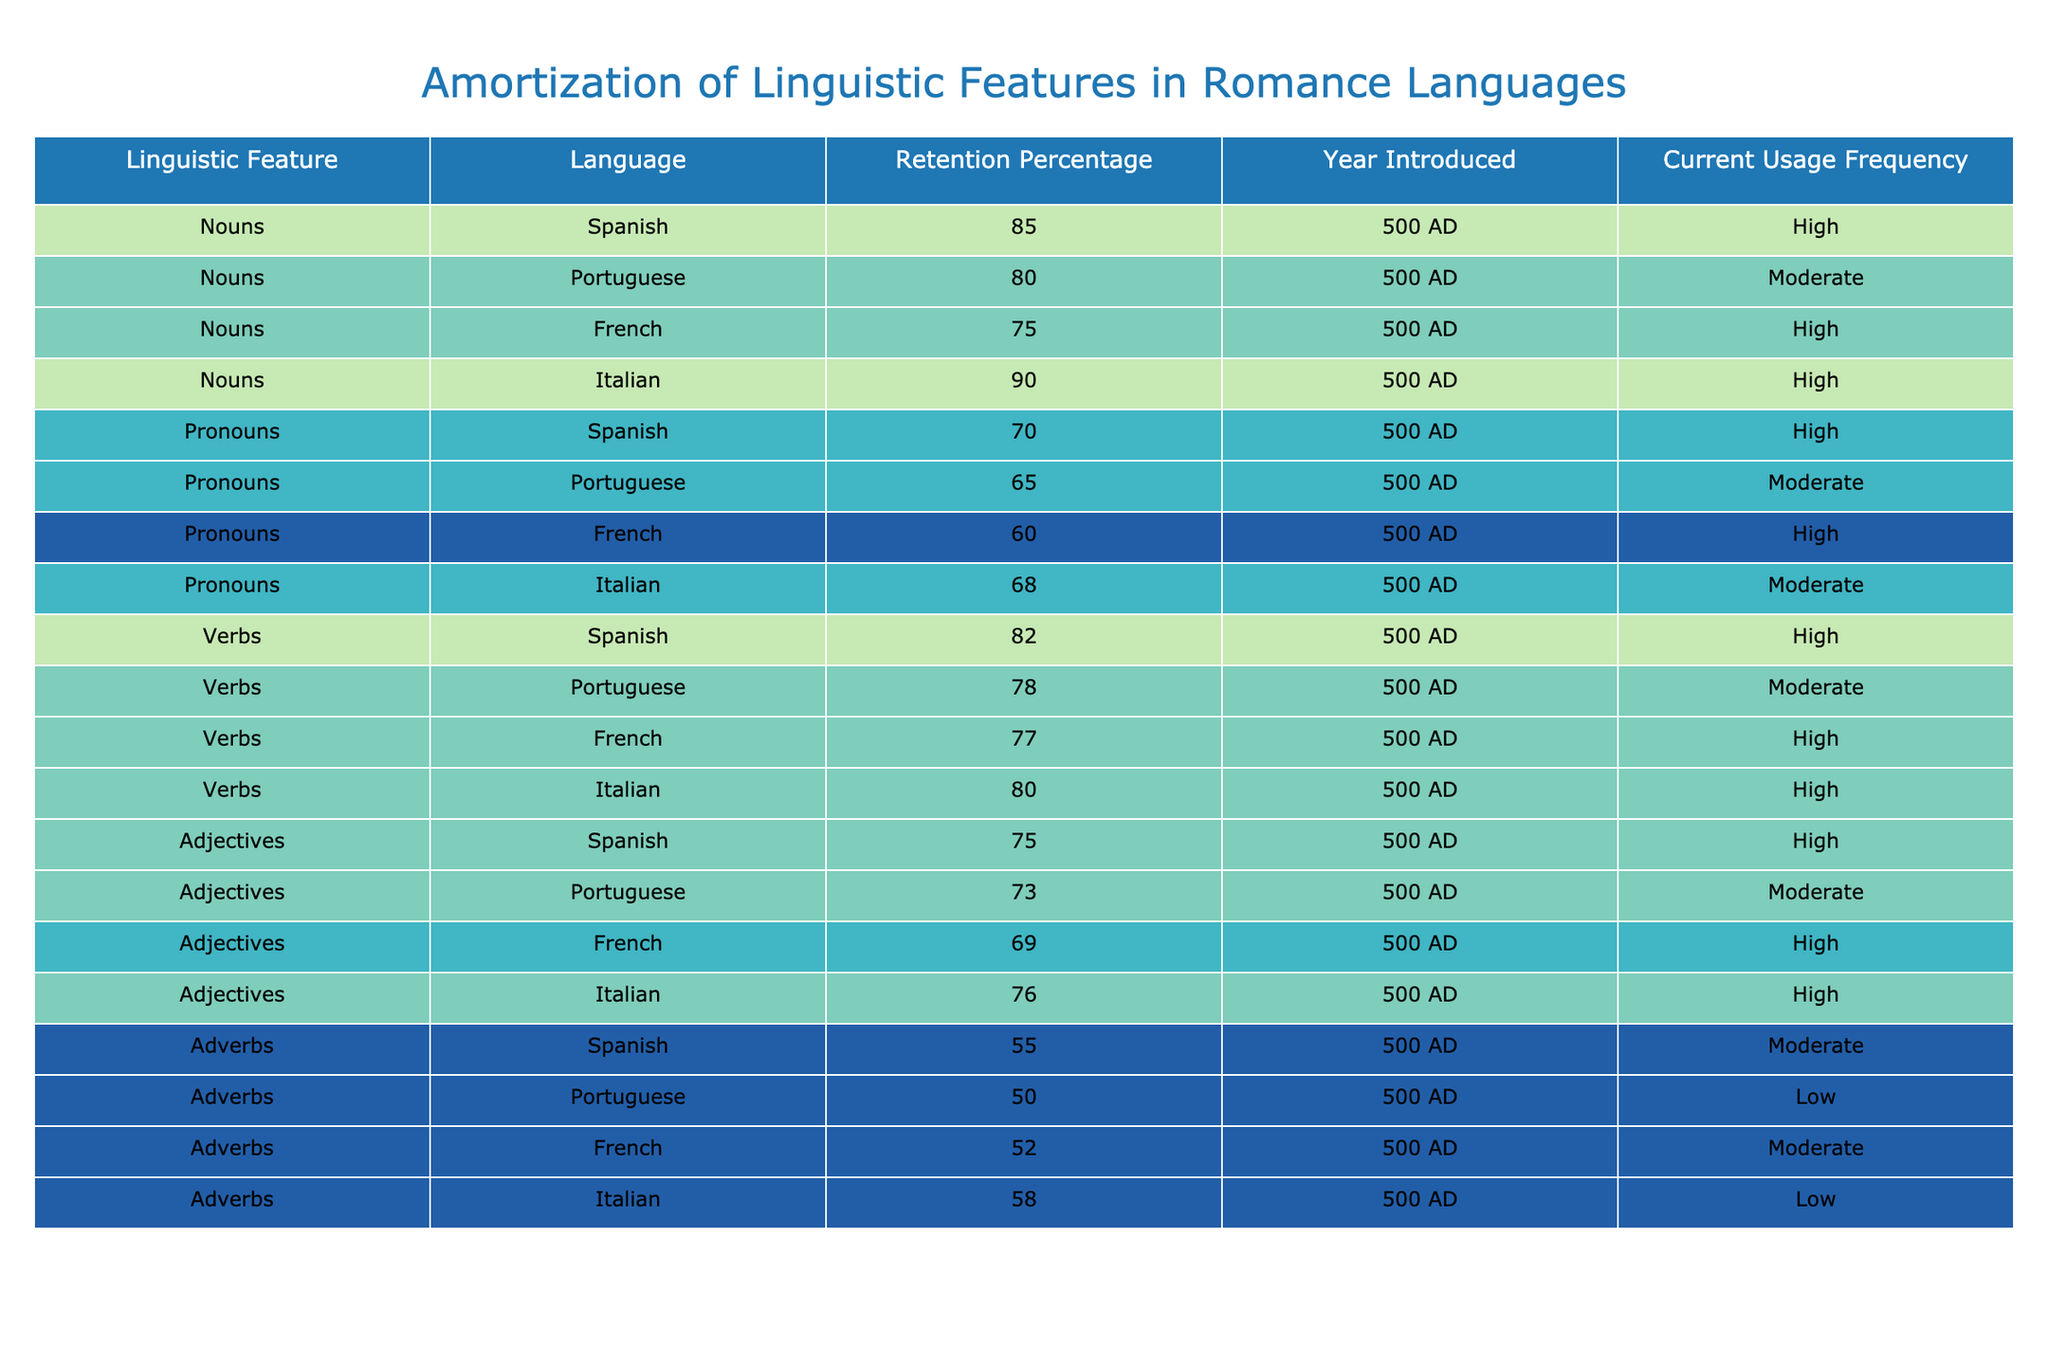What is the retention percentage of Nouns in Italian? The table shows that the retention percentage of Nouns in Italian is listed as 90%.
Answer: 90% Which language has the lowest retention percentage for Pronouns? By comparing the retention percentages listed for Pronouns, Portuguese has the lowest at 65%.
Answer: 65% What is the average retention percentage for Adverbs across all languages? The retention percentages for Adverbs are 55%, 50%, 52%, and 58%. Adding these values gives 215, and dividing by 4 (the number of languages) results in an average of 53.75%.
Answer: 53.75% Is the retention percentage for Adjectives in French greater than that in Portuguese? The retention percentage for Adjectives in French is 69%, while in Portuguese it is 73%. Since 69% is less than 73%, the statement is false.
Answer: No Which Romance language has the highest retention percentage for Verbs? The table indicates that Spanish has the highest retention percentage for Verbs at 82%.
Answer: 82% How many languages have a current usage frequency of "High" for Nouns? In the table, Spanish, French, and Italian have a current usage frequency of "High" for Nouns. This totals 3 languages.
Answer: 3 What is the retention percentage difference between Nouns in Spanish and French? The retention percentage for Nouns in Spanish is 85% and for French is 75%. The difference is 85% - 75% = 10%.
Answer: 10% Do any of the languages have a retention percentage for Adverbs that is over 60%? The retention percentages for Adverbs are 55%, 50%, 52%, and 58%, all of which are below 60%. Therefore, the answer is false.
Answer: No Which language has a retention percentage of 73% for Adjectives? The table shows that the retention percentage of Adjectives in Portuguese is 73%.
Answer: Portuguese 